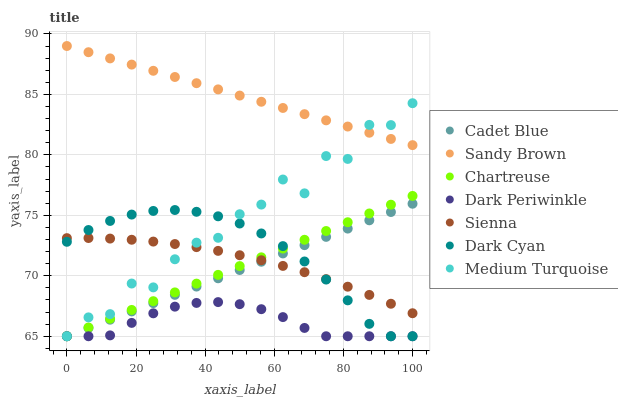Does Dark Periwinkle have the minimum area under the curve?
Answer yes or no. Yes. Does Sandy Brown have the maximum area under the curve?
Answer yes or no. Yes. Does Sienna have the minimum area under the curve?
Answer yes or no. No. Does Sienna have the maximum area under the curve?
Answer yes or no. No. Is Cadet Blue the smoothest?
Answer yes or no. Yes. Is Medium Turquoise the roughest?
Answer yes or no. Yes. Is Sienna the smoothest?
Answer yes or no. No. Is Sienna the roughest?
Answer yes or no. No. Does Cadet Blue have the lowest value?
Answer yes or no. Yes. Does Sienna have the lowest value?
Answer yes or no. No. Does Sandy Brown have the highest value?
Answer yes or no. Yes. Does Sienna have the highest value?
Answer yes or no. No. Is Sienna less than Sandy Brown?
Answer yes or no. Yes. Is Sandy Brown greater than Chartreuse?
Answer yes or no. Yes. Does Medium Turquoise intersect Dark Cyan?
Answer yes or no. Yes. Is Medium Turquoise less than Dark Cyan?
Answer yes or no. No. Is Medium Turquoise greater than Dark Cyan?
Answer yes or no. No. Does Sienna intersect Sandy Brown?
Answer yes or no. No. 